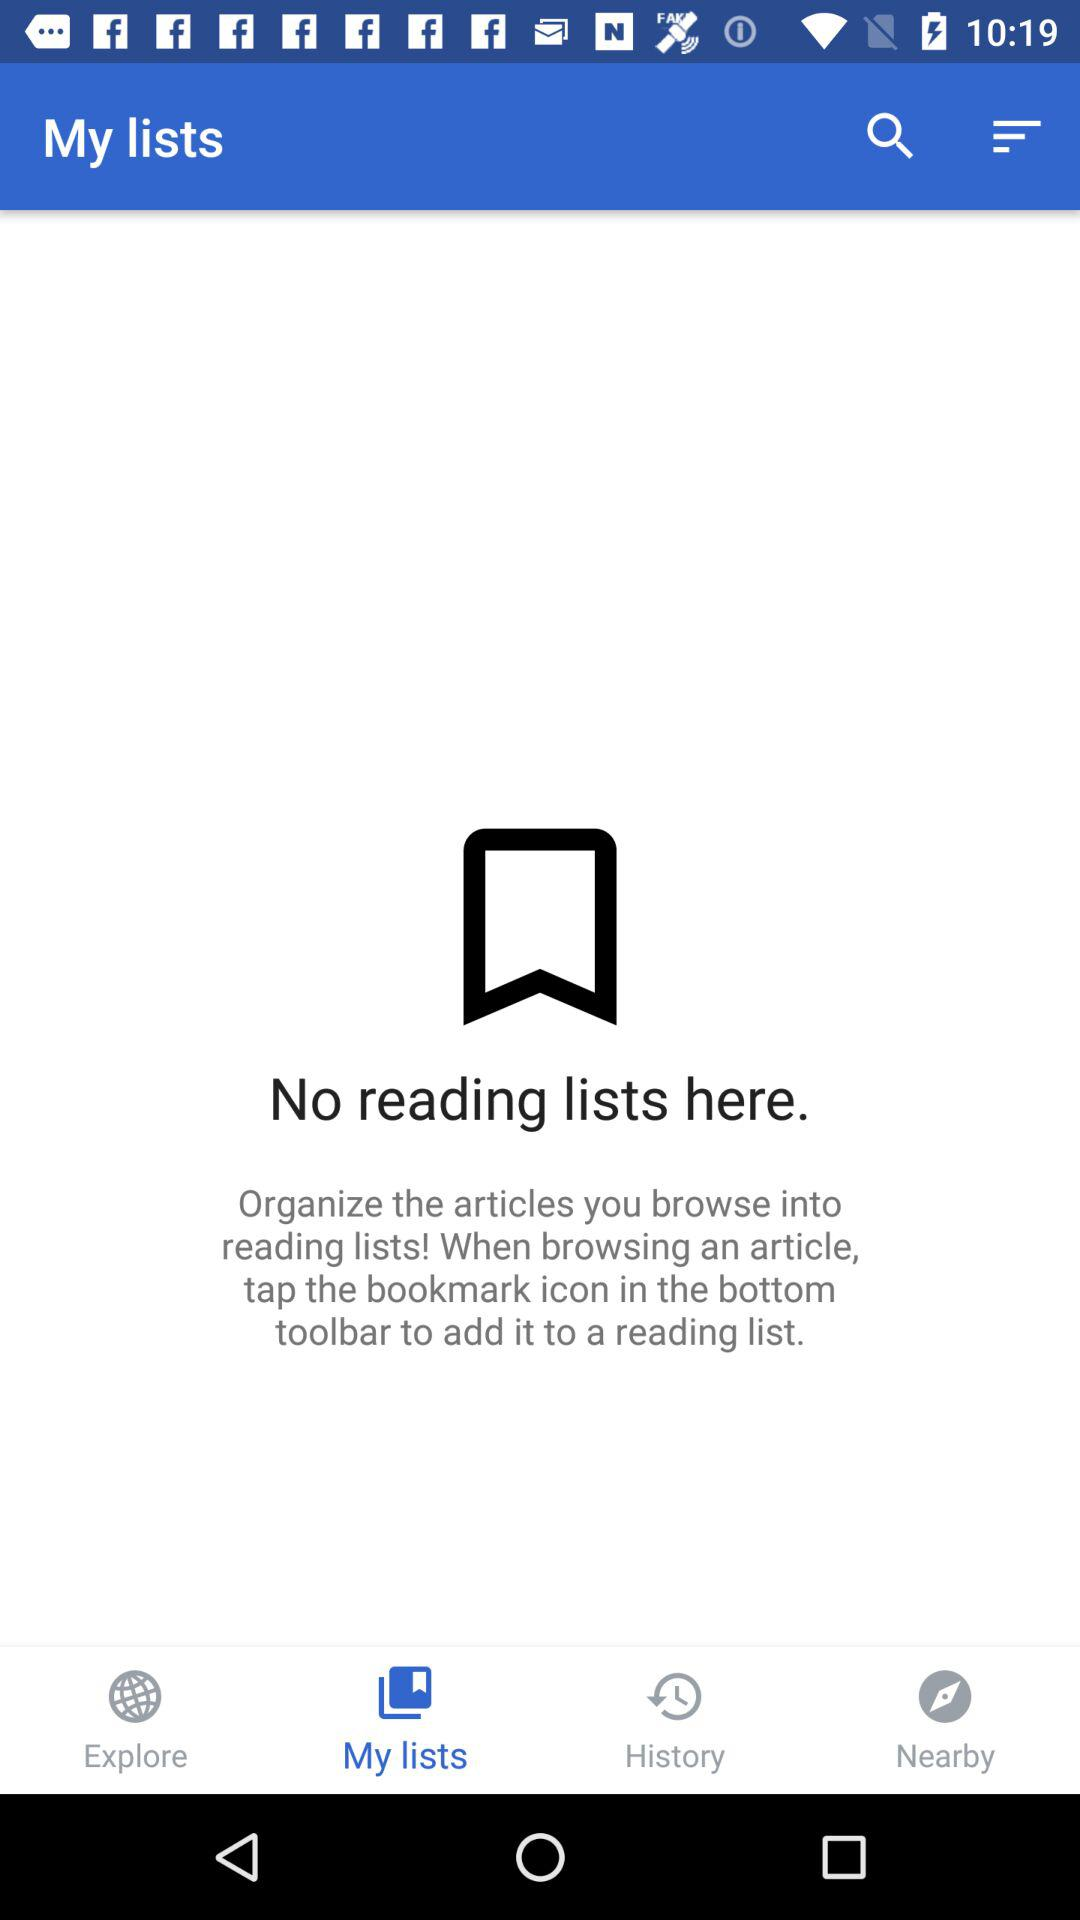Which tab is selected? The selected tab is "My lists". 